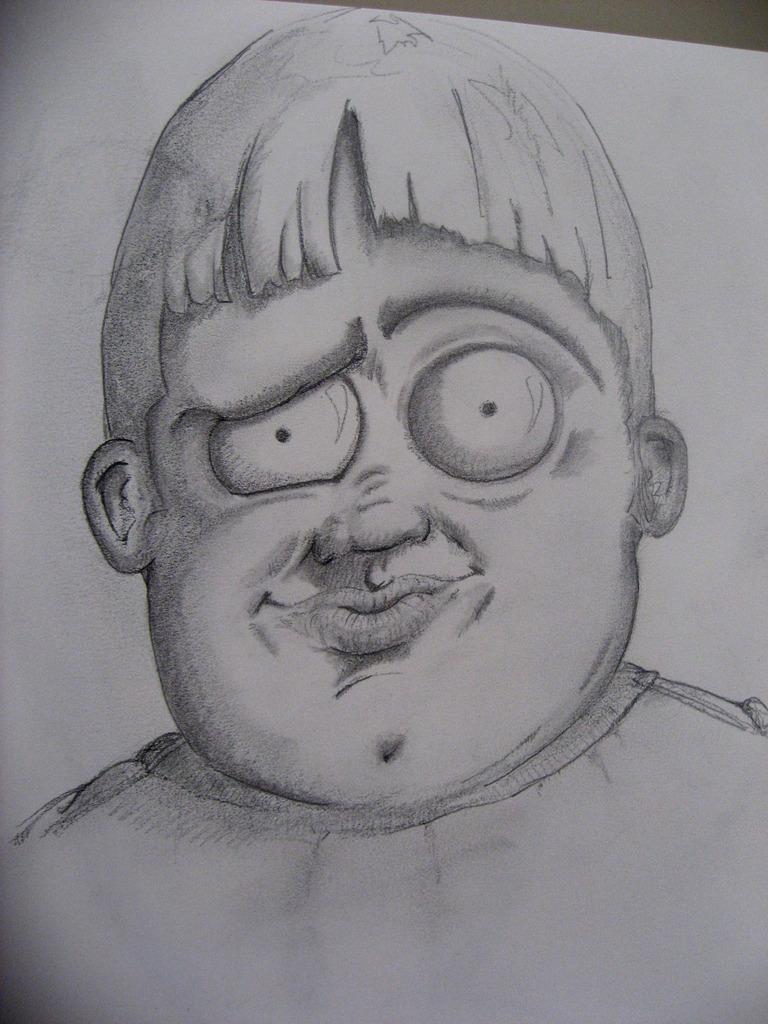Please provide a concise description of this image. This is a painting of a person on a white color paper as we can see in the middle of this image. 